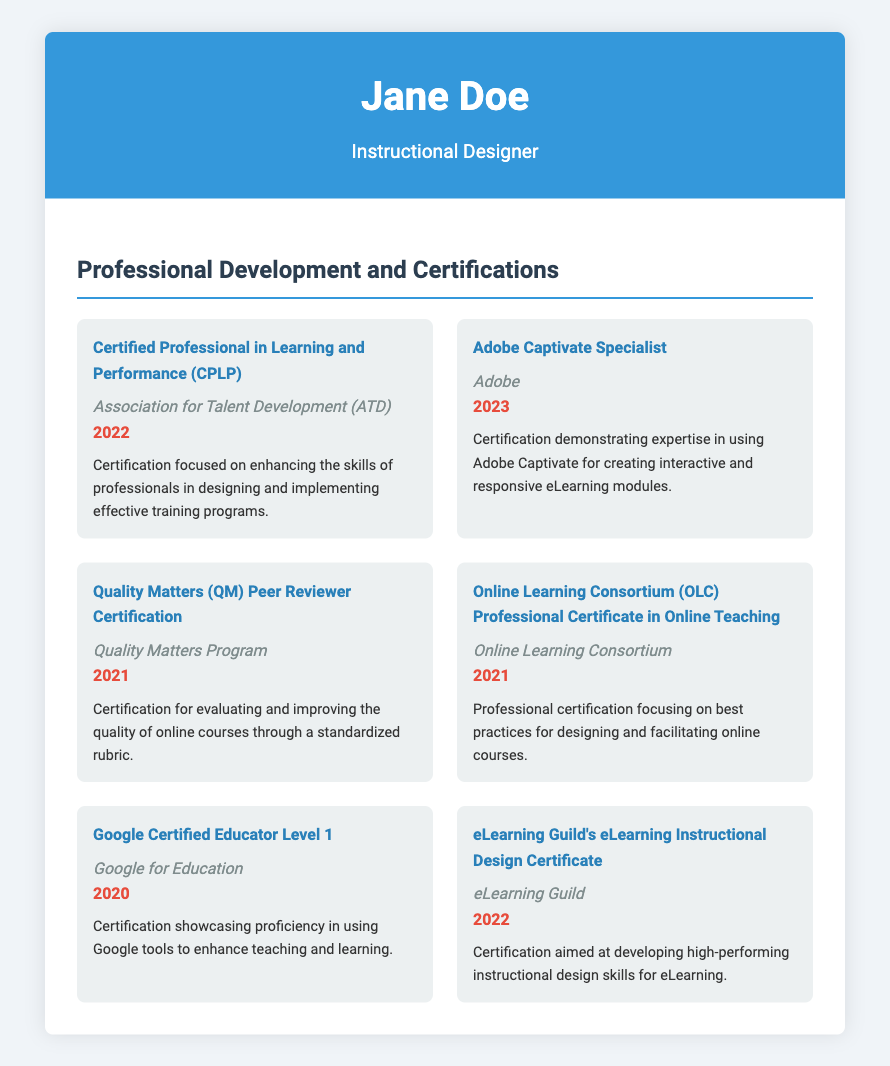what is the title of the first certification listed? The first certification listed is "Certified Professional in Learning and Performance (CPLP)."
Answer: Certified Professional in Learning and Performance (CPLP) who issued the Adobe Captivate Specialist certification? The Adobe Captivate Specialist certification was issued by Adobe.
Answer: Adobe in what year was the Quality Matters Peer Reviewer Certification obtained? The Quality Matters Peer Reviewer Certification was obtained in 2021.
Answer: 2021 how many certifications were obtained in 2022? The document lists two certifications obtained in 2022: CPLP and eLearning Instructional Design Certificate.
Answer: 2 what is the focus of the Online Learning Consortium Professional Certificate? The focus of the Online Learning Consortium Professional Certificate is on best practices for designing and facilitating online courses.
Answer: best practices for designing and facilitating online courses which certification emphasizes the use of Google tools? The certification that emphasizes the use of Google tools is "Google Certified Educator Level 1."
Answer: Google Certified Educator Level 1 what organization offers the Quality Matters Peer Reviewer Certification? The organization that offers the Quality Matters Peer Reviewer Certification is the Quality Matters Program.
Answer: Quality Matters Program which certification demonstrates expertise in creating eLearning modules? The certification that demonstrates expertise in creating eLearning modules is "Adobe Captivate Specialist."
Answer: Adobe Captivate Specialist 